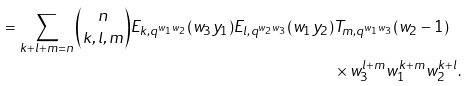Convert formula to latex. <formula><loc_0><loc_0><loc_500><loc_500>= \sum _ { k + l + m = n } \binom { n } { k , l , m } E _ { k , q ^ { w _ { 1 } w _ { 2 } } } ( w _ { 3 } y _ { 1 } ) E _ { l , q ^ { w _ { 2 } w _ { 3 } } } ( w _ { 1 } y _ { 2 } ) & T _ { m , q ^ { w _ { 1 } w _ { 3 } } } ( w _ { 2 } - 1 ) \\ & \times w _ { 3 } ^ { l + m } w _ { 1 } ^ { k + m } w _ { 2 } ^ { k + l } .</formula> 